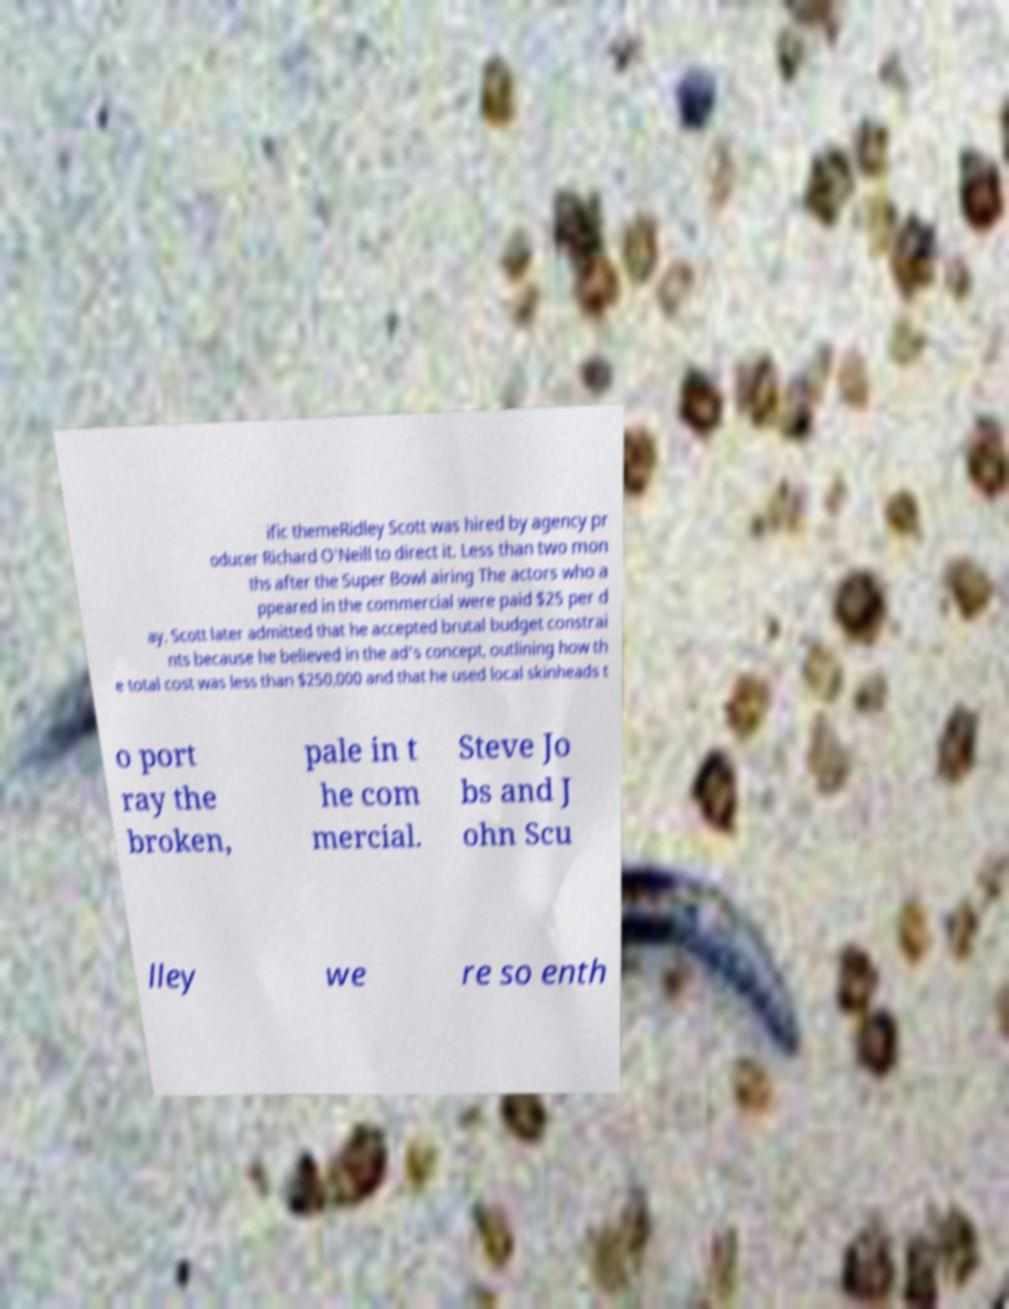I need the written content from this picture converted into text. Can you do that? ific themeRidley Scott was hired by agency pr oducer Richard O'Neill to direct it. Less than two mon ths after the Super Bowl airing The actors who a ppeared in the commercial were paid $25 per d ay. Scott later admitted that he accepted brutal budget constrai nts because he believed in the ad's concept, outlining how th e total cost was less than $250,000 and that he used local skinheads t o port ray the broken, pale in t he com mercial. Steve Jo bs and J ohn Scu lley we re so enth 